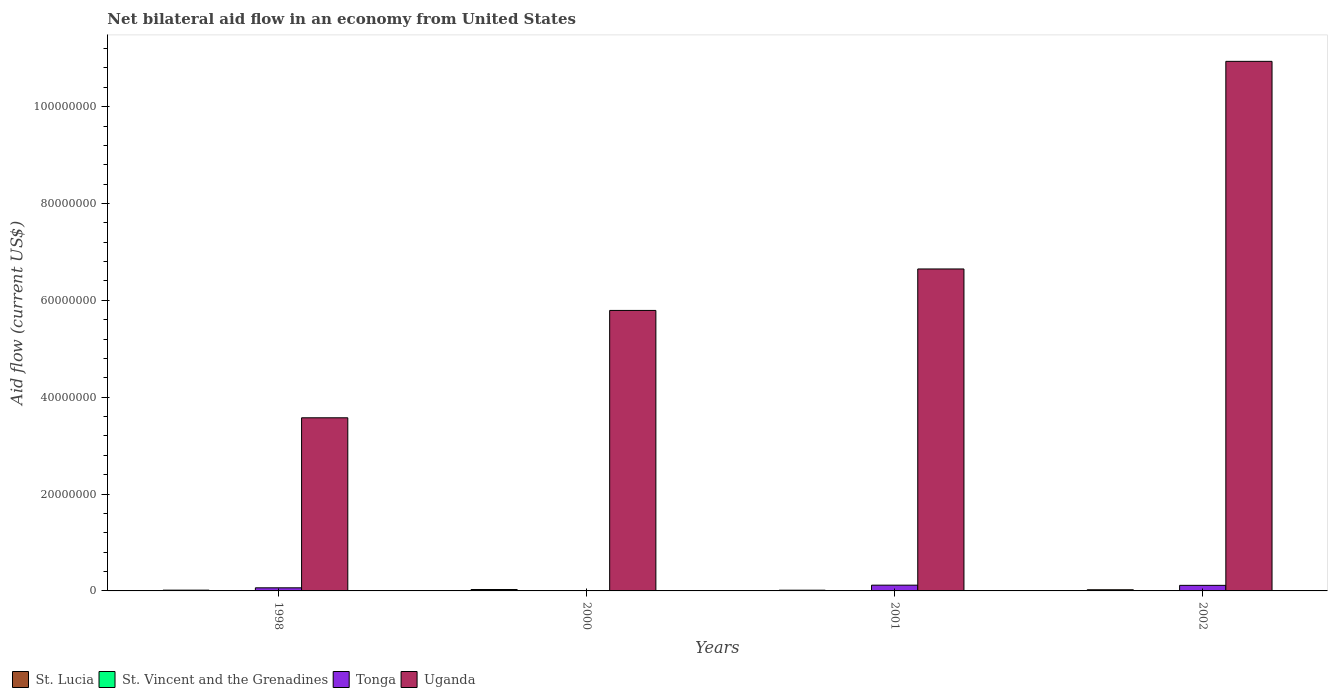How many different coloured bars are there?
Your answer should be very brief. 4. Are the number of bars per tick equal to the number of legend labels?
Provide a short and direct response. No. Are the number of bars on each tick of the X-axis equal?
Your answer should be compact. No. How many bars are there on the 2nd tick from the left?
Make the answer very short. 4. What is the label of the 2nd group of bars from the left?
Ensure brevity in your answer.  2000. In how many cases, is the number of bars for a given year not equal to the number of legend labels?
Your answer should be very brief. 2. What is the net bilateral aid flow in Uganda in 1998?
Your response must be concise. 3.58e+07. What is the total net bilateral aid flow in Uganda in the graph?
Give a very brief answer. 2.70e+08. What is the difference between the net bilateral aid flow in Uganda in 1998 and that in 2001?
Provide a short and direct response. -3.07e+07. What is the difference between the net bilateral aid flow in Uganda in 1998 and the net bilateral aid flow in St. Lucia in 2001?
Offer a very short reply. 3.56e+07. What is the average net bilateral aid flow in Tonga per year?
Provide a succinct answer. 7.52e+05. In the year 2001, what is the difference between the net bilateral aid flow in St. Lucia and net bilateral aid flow in Uganda?
Your response must be concise. -6.63e+07. In how many years, is the net bilateral aid flow in St. Vincent and the Grenadines greater than 24000000 US$?
Your response must be concise. 0. What is the ratio of the net bilateral aid flow in Tonga in 1998 to that in 2001?
Provide a succinct answer. 0.54. Is the difference between the net bilateral aid flow in St. Lucia in 1998 and 2000 greater than the difference between the net bilateral aid flow in Uganda in 1998 and 2000?
Your answer should be very brief. Yes. What is the difference between the highest and the second highest net bilateral aid flow in St. Lucia?
Make the answer very short. 5.00e+04. What is the difference between the highest and the lowest net bilateral aid flow in St. Vincent and the Grenadines?
Give a very brief answer. 3.00e+04. Is it the case that in every year, the sum of the net bilateral aid flow in St. Vincent and the Grenadines and net bilateral aid flow in St. Lucia is greater than the sum of net bilateral aid flow in Tonga and net bilateral aid flow in Uganda?
Ensure brevity in your answer.  No. How many bars are there?
Provide a succinct answer. 14. Are all the bars in the graph horizontal?
Provide a succinct answer. No. What is the difference between two consecutive major ticks on the Y-axis?
Offer a very short reply. 2.00e+07. Are the values on the major ticks of Y-axis written in scientific E-notation?
Give a very brief answer. No. Does the graph contain grids?
Make the answer very short. No. Where does the legend appear in the graph?
Keep it short and to the point. Bottom left. How are the legend labels stacked?
Ensure brevity in your answer.  Horizontal. What is the title of the graph?
Your answer should be compact. Net bilateral aid flow in an economy from United States. Does "Guyana" appear as one of the legend labels in the graph?
Make the answer very short. No. What is the label or title of the Y-axis?
Provide a short and direct response. Aid flow (current US$). What is the Aid flow (current US$) of Tonga in 1998?
Keep it short and to the point. 6.40e+05. What is the Aid flow (current US$) in Uganda in 1998?
Offer a very short reply. 3.58e+07. What is the Aid flow (current US$) in St. Lucia in 2000?
Offer a very short reply. 2.90e+05. What is the Aid flow (current US$) in Uganda in 2000?
Your answer should be compact. 5.79e+07. What is the Aid flow (current US$) in St. Vincent and the Grenadines in 2001?
Your answer should be very brief. 0. What is the Aid flow (current US$) of Tonga in 2001?
Offer a terse response. 1.19e+06. What is the Aid flow (current US$) of Uganda in 2001?
Your answer should be compact. 6.65e+07. What is the Aid flow (current US$) in St. Lucia in 2002?
Your answer should be very brief. 2.40e+05. What is the Aid flow (current US$) of St. Vincent and the Grenadines in 2002?
Your answer should be compact. 10000. What is the Aid flow (current US$) in Tonga in 2002?
Your answer should be very brief. 1.15e+06. What is the Aid flow (current US$) in Uganda in 2002?
Your response must be concise. 1.09e+08. Across all years, what is the maximum Aid flow (current US$) of St. Vincent and the Grenadines?
Offer a terse response. 3.00e+04. Across all years, what is the maximum Aid flow (current US$) of Tonga?
Give a very brief answer. 1.19e+06. Across all years, what is the maximum Aid flow (current US$) in Uganda?
Give a very brief answer. 1.09e+08. Across all years, what is the minimum Aid flow (current US$) in St. Lucia?
Provide a succinct answer. 1.50e+05. Across all years, what is the minimum Aid flow (current US$) of Tonga?
Keep it short and to the point. 3.00e+04. Across all years, what is the minimum Aid flow (current US$) of Uganda?
Offer a very short reply. 3.58e+07. What is the total Aid flow (current US$) in St. Lucia in the graph?
Ensure brevity in your answer.  8.40e+05. What is the total Aid flow (current US$) in St. Vincent and the Grenadines in the graph?
Offer a very short reply. 4.00e+04. What is the total Aid flow (current US$) of Tonga in the graph?
Offer a terse response. 3.01e+06. What is the total Aid flow (current US$) in Uganda in the graph?
Give a very brief answer. 2.70e+08. What is the difference between the Aid flow (current US$) in St. Lucia in 1998 and that in 2000?
Your response must be concise. -1.30e+05. What is the difference between the Aid flow (current US$) of Tonga in 1998 and that in 2000?
Offer a terse response. 6.10e+05. What is the difference between the Aid flow (current US$) of Uganda in 1998 and that in 2000?
Offer a very short reply. -2.22e+07. What is the difference between the Aid flow (current US$) of Tonga in 1998 and that in 2001?
Give a very brief answer. -5.50e+05. What is the difference between the Aid flow (current US$) of Uganda in 1998 and that in 2001?
Keep it short and to the point. -3.07e+07. What is the difference between the Aid flow (current US$) in Tonga in 1998 and that in 2002?
Give a very brief answer. -5.10e+05. What is the difference between the Aid flow (current US$) of Uganda in 1998 and that in 2002?
Provide a short and direct response. -7.36e+07. What is the difference between the Aid flow (current US$) of Tonga in 2000 and that in 2001?
Offer a terse response. -1.16e+06. What is the difference between the Aid flow (current US$) in Uganda in 2000 and that in 2001?
Your response must be concise. -8.56e+06. What is the difference between the Aid flow (current US$) of Tonga in 2000 and that in 2002?
Offer a very short reply. -1.12e+06. What is the difference between the Aid flow (current US$) of Uganda in 2000 and that in 2002?
Keep it short and to the point. -5.14e+07. What is the difference between the Aid flow (current US$) of Uganda in 2001 and that in 2002?
Provide a succinct answer. -4.29e+07. What is the difference between the Aid flow (current US$) of St. Lucia in 1998 and the Aid flow (current US$) of Uganda in 2000?
Offer a terse response. -5.78e+07. What is the difference between the Aid flow (current US$) in Tonga in 1998 and the Aid flow (current US$) in Uganda in 2000?
Make the answer very short. -5.73e+07. What is the difference between the Aid flow (current US$) in St. Lucia in 1998 and the Aid flow (current US$) in Tonga in 2001?
Offer a terse response. -1.03e+06. What is the difference between the Aid flow (current US$) of St. Lucia in 1998 and the Aid flow (current US$) of Uganda in 2001?
Make the answer very short. -6.63e+07. What is the difference between the Aid flow (current US$) of Tonga in 1998 and the Aid flow (current US$) of Uganda in 2001?
Provide a short and direct response. -6.58e+07. What is the difference between the Aid flow (current US$) in St. Lucia in 1998 and the Aid flow (current US$) in Tonga in 2002?
Ensure brevity in your answer.  -9.90e+05. What is the difference between the Aid flow (current US$) of St. Lucia in 1998 and the Aid flow (current US$) of Uganda in 2002?
Provide a short and direct response. -1.09e+08. What is the difference between the Aid flow (current US$) in Tonga in 1998 and the Aid flow (current US$) in Uganda in 2002?
Give a very brief answer. -1.09e+08. What is the difference between the Aid flow (current US$) of St. Lucia in 2000 and the Aid flow (current US$) of Tonga in 2001?
Keep it short and to the point. -9.00e+05. What is the difference between the Aid flow (current US$) in St. Lucia in 2000 and the Aid flow (current US$) in Uganda in 2001?
Ensure brevity in your answer.  -6.62e+07. What is the difference between the Aid flow (current US$) of St. Vincent and the Grenadines in 2000 and the Aid flow (current US$) of Tonga in 2001?
Offer a very short reply. -1.16e+06. What is the difference between the Aid flow (current US$) of St. Vincent and the Grenadines in 2000 and the Aid flow (current US$) of Uganda in 2001?
Provide a succinct answer. -6.64e+07. What is the difference between the Aid flow (current US$) in Tonga in 2000 and the Aid flow (current US$) in Uganda in 2001?
Give a very brief answer. -6.64e+07. What is the difference between the Aid flow (current US$) in St. Lucia in 2000 and the Aid flow (current US$) in St. Vincent and the Grenadines in 2002?
Provide a succinct answer. 2.80e+05. What is the difference between the Aid flow (current US$) in St. Lucia in 2000 and the Aid flow (current US$) in Tonga in 2002?
Ensure brevity in your answer.  -8.60e+05. What is the difference between the Aid flow (current US$) in St. Lucia in 2000 and the Aid flow (current US$) in Uganda in 2002?
Provide a short and direct response. -1.09e+08. What is the difference between the Aid flow (current US$) in St. Vincent and the Grenadines in 2000 and the Aid flow (current US$) in Tonga in 2002?
Provide a short and direct response. -1.12e+06. What is the difference between the Aid flow (current US$) of St. Vincent and the Grenadines in 2000 and the Aid flow (current US$) of Uganda in 2002?
Ensure brevity in your answer.  -1.09e+08. What is the difference between the Aid flow (current US$) of Tonga in 2000 and the Aid flow (current US$) of Uganda in 2002?
Offer a very short reply. -1.09e+08. What is the difference between the Aid flow (current US$) of St. Lucia in 2001 and the Aid flow (current US$) of St. Vincent and the Grenadines in 2002?
Your answer should be compact. 1.40e+05. What is the difference between the Aid flow (current US$) in St. Lucia in 2001 and the Aid flow (current US$) in Uganda in 2002?
Make the answer very short. -1.09e+08. What is the difference between the Aid flow (current US$) in Tonga in 2001 and the Aid flow (current US$) in Uganda in 2002?
Make the answer very short. -1.08e+08. What is the average Aid flow (current US$) of St. Vincent and the Grenadines per year?
Give a very brief answer. 10000. What is the average Aid flow (current US$) in Tonga per year?
Keep it short and to the point. 7.52e+05. What is the average Aid flow (current US$) of Uganda per year?
Ensure brevity in your answer.  6.74e+07. In the year 1998, what is the difference between the Aid flow (current US$) in St. Lucia and Aid flow (current US$) in Tonga?
Give a very brief answer. -4.80e+05. In the year 1998, what is the difference between the Aid flow (current US$) in St. Lucia and Aid flow (current US$) in Uganda?
Ensure brevity in your answer.  -3.56e+07. In the year 1998, what is the difference between the Aid flow (current US$) of Tonga and Aid flow (current US$) of Uganda?
Offer a terse response. -3.51e+07. In the year 2000, what is the difference between the Aid flow (current US$) in St. Lucia and Aid flow (current US$) in St. Vincent and the Grenadines?
Give a very brief answer. 2.60e+05. In the year 2000, what is the difference between the Aid flow (current US$) in St. Lucia and Aid flow (current US$) in Uganda?
Make the answer very short. -5.76e+07. In the year 2000, what is the difference between the Aid flow (current US$) of St. Vincent and the Grenadines and Aid flow (current US$) of Tonga?
Provide a succinct answer. 0. In the year 2000, what is the difference between the Aid flow (current US$) in St. Vincent and the Grenadines and Aid flow (current US$) in Uganda?
Offer a very short reply. -5.79e+07. In the year 2000, what is the difference between the Aid flow (current US$) in Tonga and Aid flow (current US$) in Uganda?
Your answer should be very brief. -5.79e+07. In the year 2001, what is the difference between the Aid flow (current US$) of St. Lucia and Aid flow (current US$) of Tonga?
Your answer should be compact. -1.04e+06. In the year 2001, what is the difference between the Aid flow (current US$) in St. Lucia and Aid flow (current US$) in Uganda?
Keep it short and to the point. -6.63e+07. In the year 2001, what is the difference between the Aid flow (current US$) of Tonga and Aid flow (current US$) of Uganda?
Keep it short and to the point. -6.53e+07. In the year 2002, what is the difference between the Aid flow (current US$) of St. Lucia and Aid flow (current US$) of St. Vincent and the Grenadines?
Your answer should be compact. 2.30e+05. In the year 2002, what is the difference between the Aid flow (current US$) in St. Lucia and Aid flow (current US$) in Tonga?
Offer a very short reply. -9.10e+05. In the year 2002, what is the difference between the Aid flow (current US$) of St. Lucia and Aid flow (current US$) of Uganda?
Give a very brief answer. -1.09e+08. In the year 2002, what is the difference between the Aid flow (current US$) of St. Vincent and the Grenadines and Aid flow (current US$) of Tonga?
Make the answer very short. -1.14e+06. In the year 2002, what is the difference between the Aid flow (current US$) of St. Vincent and the Grenadines and Aid flow (current US$) of Uganda?
Offer a terse response. -1.09e+08. In the year 2002, what is the difference between the Aid flow (current US$) in Tonga and Aid flow (current US$) in Uganda?
Offer a very short reply. -1.08e+08. What is the ratio of the Aid flow (current US$) of St. Lucia in 1998 to that in 2000?
Give a very brief answer. 0.55. What is the ratio of the Aid flow (current US$) of Tonga in 1998 to that in 2000?
Provide a short and direct response. 21.33. What is the ratio of the Aid flow (current US$) of Uganda in 1998 to that in 2000?
Your answer should be compact. 0.62. What is the ratio of the Aid flow (current US$) of St. Lucia in 1998 to that in 2001?
Make the answer very short. 1.07. What is the ratio of the Aid flow (current US$) of Tonga in 1998 to that in 2001?
Keep it short and to the point. 0.54. What is the ratio of the Aid flow (current US$) in Uganda in 1998 to that in 2001?
Provide a succinct answer. 0.54. What is the ratio of the Aid flow (current US$) in Tonga in 1998 to that in 2002?
Your answer should be compact. 0.56. What is the ratio of the Aid flow (current US$) in Uganda in 1998 to that in 2002?
Provide a succinct answer. 0.33. What is the ratio of the Aid flow (current US$) in St. Lucia in 2000 to that in 2001?
Your response must be concise. 1.93. What is the ratio of the Aid flow (current US$) of Tonga in 2000 to that in 2001?
Your answer should be compact. 0.03. What is the ratio of the Aid flow (current US$) in Uganda in 2000 to that in 2001?
Make the answer very short. 0.87. What is the ratio of the Aid flow (current US$) in St. Lucia in 2000 to that in 2002?
Your response must be concise. 1.21. What is the ratio of the Aid flow (current US$) of St. Vincent and the Grenadines in 2000 to that in 2002?
Your response must be concise. 3. What is the ratio of the Aid flow (current US$) in Tonga in 2000 to that in 2002?
Your answer should be very brief. 0.03. What is the ratio of the Aid flow (current US$) of Uganda in 2000 to that in 2002?
Provide a short and direct response. 0.53. What is the ratio of the Aid flow (current US$) in St. Lucia in 2001 to that in 2002?
Keep it short and to the point. 0.62. What is the ratio of the Aid flow (current US$) in Tonga in 2001 to that in 2002?
Keep it short and to the point. 1.03. What is the ratio of the Aid flow (current US$) in Uganda in 2001 to that in 2002?
Make the answer very short. 0.61. What is the difference between the highest and the second highest Aid flow (current US$) of Uganda?
Provide a succinct answer. 4.29e+07. What is the difference between the highest and the lowest Aid flow (current US$) of Tonga?
Your response must be concise. 1.16e+06. What is the difference between the highest and the lowest Aid flow (current US$) of Uganda?
Your response must be concise. 7.36e+07. 